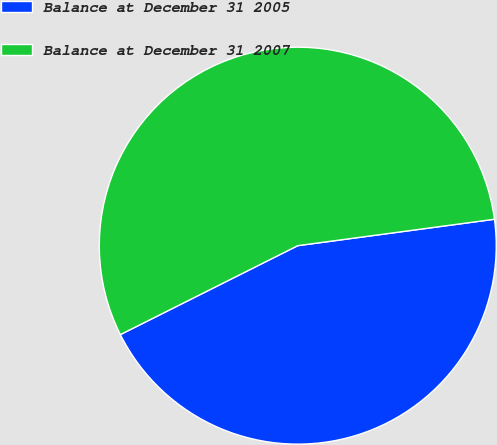<chart> <loc_0><loc_0><loc_500><loc_500><pie_chart><fcel>Balance at December 31 2005<fcel>Balance at December 31 2007<nl><fcel>44.73%<fcel>55.27%<nl></chart> 